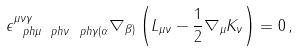<formula> <loc_0><loc_0><loc_500><loc_500>\epsilon ^ { \mu \nu \gamma } _ { \ p h { \mu } \ p h { \nu } \ p h { \gamma } ( \alpha } \nabla _ { \beta ) } \left ( L _ { \mu \nu } - \frac { 1 } { 2 } \nabla _ { \mu } K _ { \nu } \right ) = 0 \, ,</formula> 